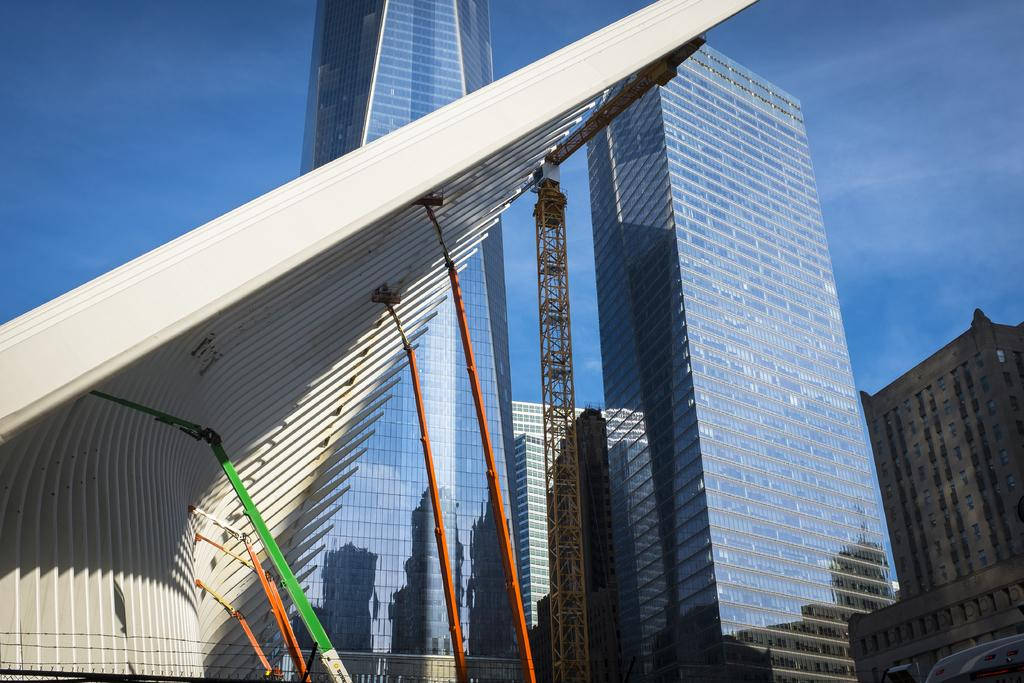What structures are located on the left side of the image? There is a building on the left side of the image. What structures are located on the right side of the image? There is a building on the right side of the image. Can you describe the buildings in the image? Unfortunately, the provided facts do not include any details about the appearance or characteristics of the buildings. What type of sweater is the insect wearing while using the whip in the image? There is no insect, sweater, or whip present in the image. 